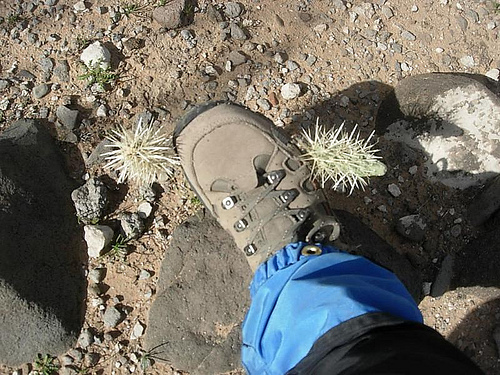<image>
Is the plant next to the boot? Yes. The plant is positioned adjacent to the boot, located nearby in the same general area. 